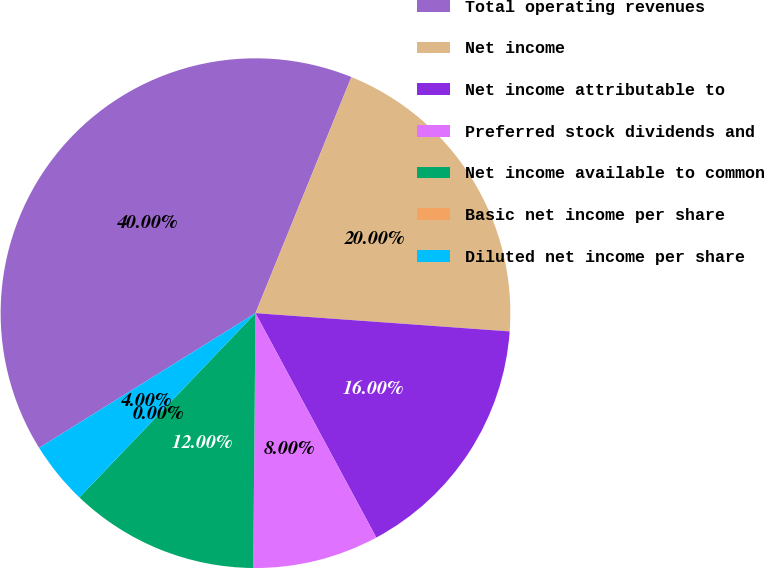Convert chart. <chart><loc_0><loc_0><loc_500><loc_500><pie_chart><fcel>Total operating revenues<fcel>Net income<fcel>Net income attributable to<fcel>Preferred stock dividends and<fcel>Net income available to common<fcel>Basic net income per share<fcel>Diluted net income per share<nl><fcel>40.0%<fcel>20.0%<fcel>16.0%<fcel>8.0%<fcel>12.0%<fcel>0.0%<fcel>4.0%<nl></chart> 